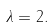Convert formula to latex. <formula><loc_0><loc_0><loc_500><loc_500>\lambda = 2 .</formula> 